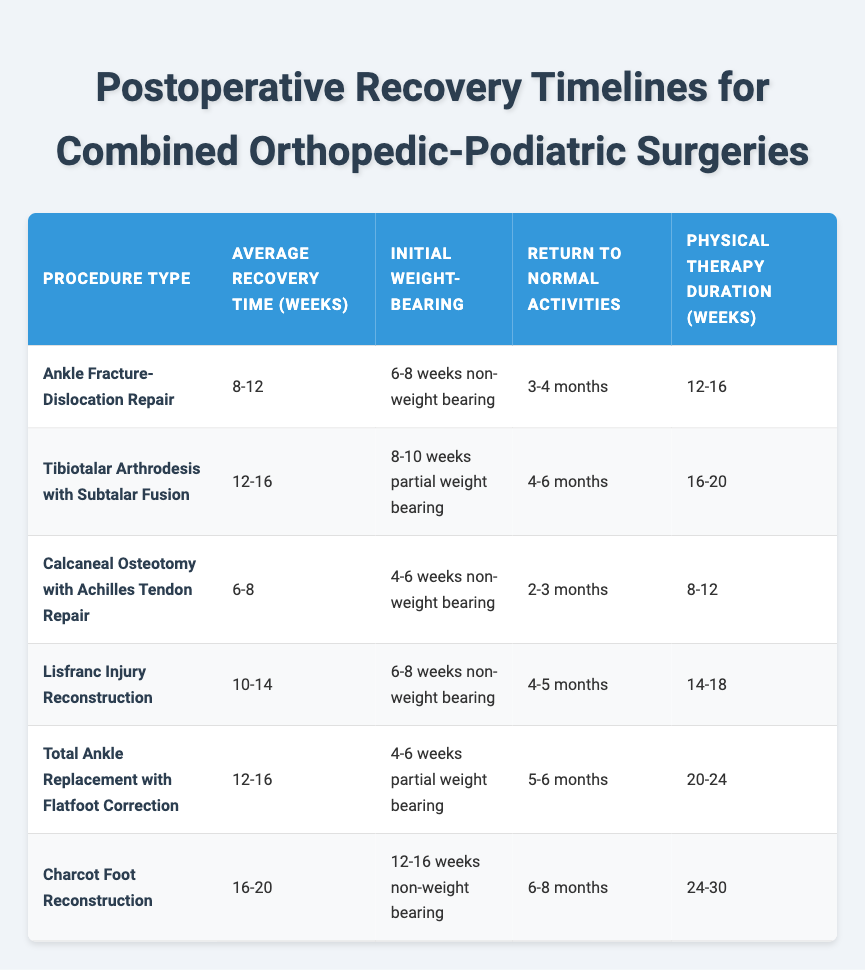What is the average recovery time for the Tibiotalar Arthrodesis with Subtalar Fusion procedure? The average recovery time for the Tibiotalar Arthrodesis with Subtalar Fusion procedure is listed as 12-16 weeks in the table.
Answer: 12-16 weeks How many weeks of physical therapy are typically required after a Charcot Foot Reconstruction? The physical therapy duration after Charcot Foot Reconstruction is indicated as 24-30 weeks in the table.
Answer: 24-30 weeks Is the initial weight-bearing for the Calcaneal Osteotomy with Achilles Tendon Repair a non-weight bearing period? The table shows that the initial weight-bearing for the Calcaneal Osteotomy with Achilles Tendon Repair is 4-6 weeks non-weight bearing, making the statement true.
Answer: Yes What is the difference in average recovery time between the Ankle Fracture-Dislocation Repair and the Lisfranc Injury Reconstruction? The average recovery time for Ankle Fracture-Dislocation Repair is 8-12 weeks and for Lisfranc Injury Reconstruction it is 10-14 weeks. To find the difference, we calculate the average for both: Ankle - 10 weeks, Lisfranc - 12 weeks. The difference is 12 - 10 = 2 weeks.
Answer: 2 weeks Which procedure requires the longest initial non-weight bearing period? The Charcot Foot Reconstruction has an initial weight-bearing period of 12-16 weeks non-weight bearing, which is longer than any other procedure listed in the table.
Answer: Charcot Foot Reconstruction How many months does it generally take for a patient to return to normal activities after a Total Ankle Replacement with Flatfoot Correction? The table indicates that returning to normal activities after a Total Ankle Replacement with Flatfoot Correction typically requires 5-6 months.
Answer: 5-6 months What procedure has the shortest average recovery time, and what is that time? The Calcaneal Osteotomy with Achilles Tendon Repair has the shortest average recovery time of 6-8 weeks according to the table, which we can verify by comparing all the average recovery times presented.
Answer: 6-8 weeks For the Tibiotalar Arthrodesis with Subtalar Fusion, what is the duration for physical therapy? The table specifies that the physical therapy duration after the Tibiotalar Arthrodesis with Subtalar Fusion is 16-20 weeks.
Answer: 16-20 weeks Is it true that all procedures listed have an average recovery time of at least 8 weeks? Checking each procedure: Ankle Fracture-Dislocation Repair (8-12), Tibiotalar Arthrodesis (12-16), Calcaneal Osteotomy (6-8), Lisfranc Injury Reconstruction (10-14), Total Ankle Replacement (12-16), Charcot Foot Reconstruction (16-20). The Calcaneal Osteotomy has an average recovery time as low as 6 weeks; therefore, the statement is false.
Answer: No 